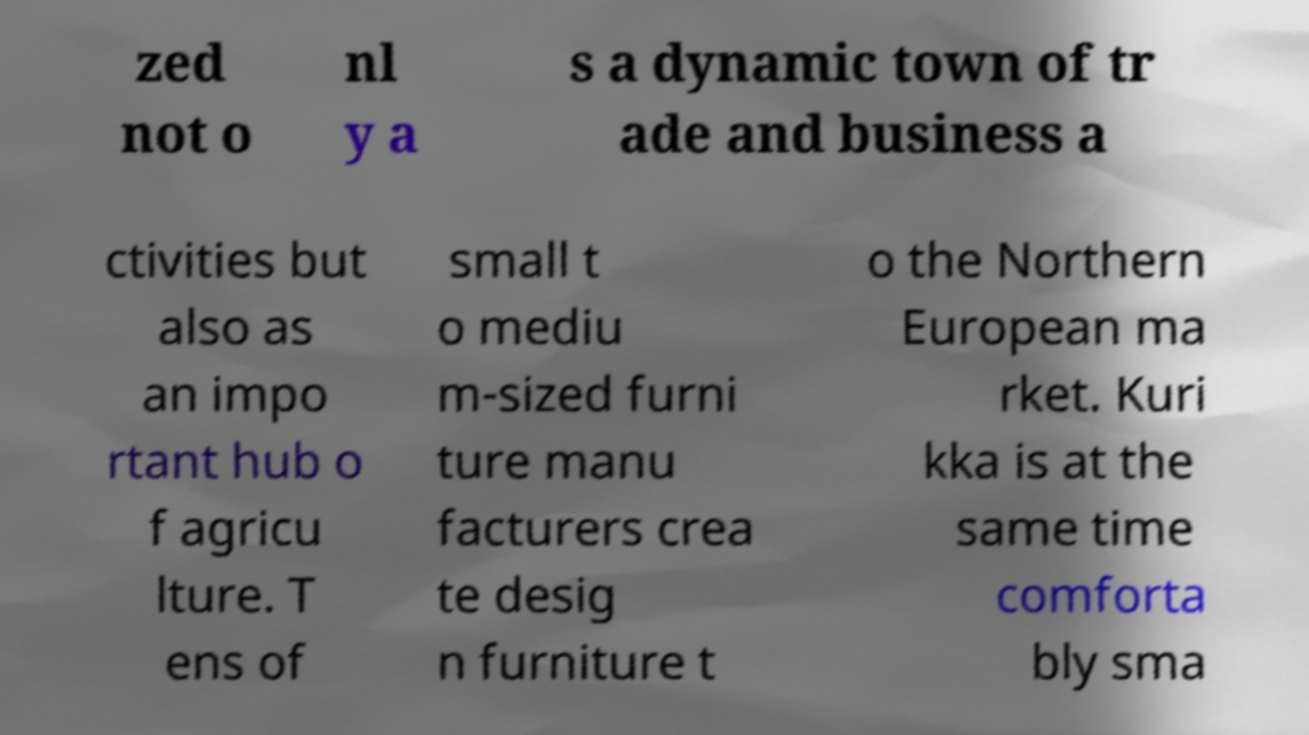For documentation purposes, I need the text within this image transcribed. Could you provide that? zed not o nl y a s a dynamic town of tr ade and business a ctivities but also as an impo rtant hub o f agricu lture. T ens of small t o mediu m-sized furni ture manu facturers crea te desig n furniture t o the Northern European ma rket. Kuri kka is at the same time comforta bly sma 